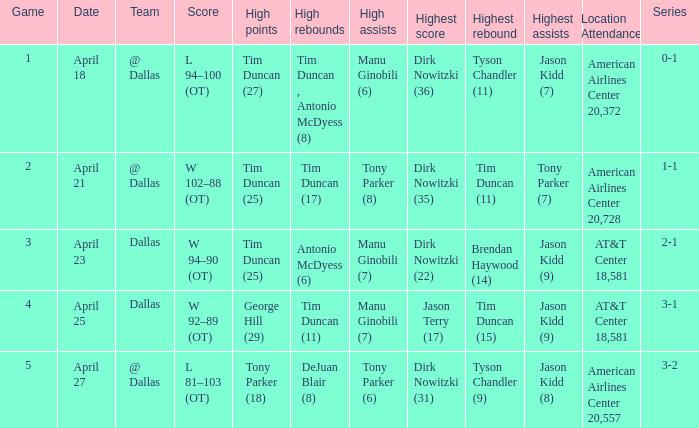When 0-1 is the series who has the highest amount of assists? Manu Ginobili (6). 